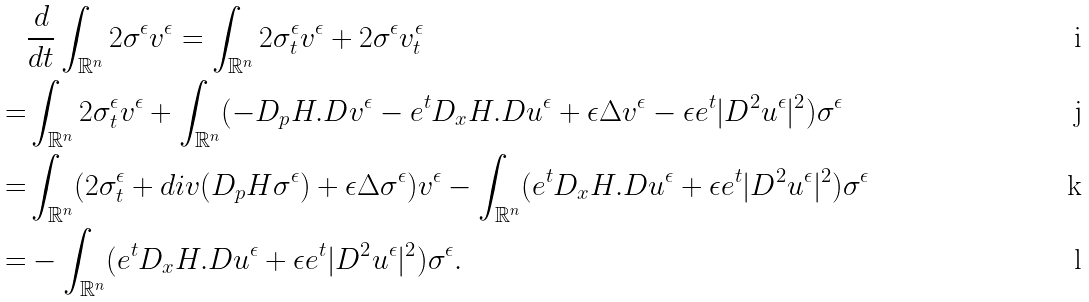Convert formula to latex. <formula><loc_0><loc_0><loc_500><loc_500>& \frac { d } { d t } \int _ { \mathbb { R } ^ { n } } 2 \sigma ^ { \epsilon } v ^ { \epsilon } = \int _ { \mathbb { R } ^ { n } } 2 \sigma ^ { \epsilon } _ { t } v ^ { \epsilon } + 2 \sigma ^ { \epsilon } v ^ { \epsilon } _ { t } \quad \\ = & \int _ { \mathbb { R } ^ { n } } 2 \sigma ^ { \epsilon } _ { t } v ^ { \epsilon } + \int _ { \mathbb { R } ^ { n } } ( - D _ { p } H . D v ^ { \epsilon } - e ^ { t } D _ { x } H . D u ^ { \epsilon } + \epsilon \Delta v ^ { \epsilon } - \epsilon e ^ { t } | D ^ { 2 } u ^ { \epsilon } | ^ { 2 } ) \sigma ^ { \epsilon } \quad \\ = & \int _ { \mathbb { R } ^ { n } } ( 2 \sigma ^ { \epsilon } _ { t } + d i v ( D _ { p } H \sigma ^ { \epsilon } ) + \epsilon \Delta \sigma ^ { \epsilon } ) v ^ { \epsilon } - \int _ { \mathbb { R } ^ { n } } ( e ^ { t } D _ { x } H . D u ^ { \epsilon } + \epsilon e ^ { t } | D ^ { 2 } u ^ { \epsilon } | ^ { 2 } ) \sigma ^ { \epsilon } \quad \\ = & - \int _ { \mathbb { R } ^ { n } } ( e ^ { t } D _ { x } H . D u ^ { \epsilon } + \epsilon e ^ { t } | D ^ { 2 } u ^ { \epsilon } | ^ { 2 } ) \sigma ^ { \epsilon } . \quad</formula> 